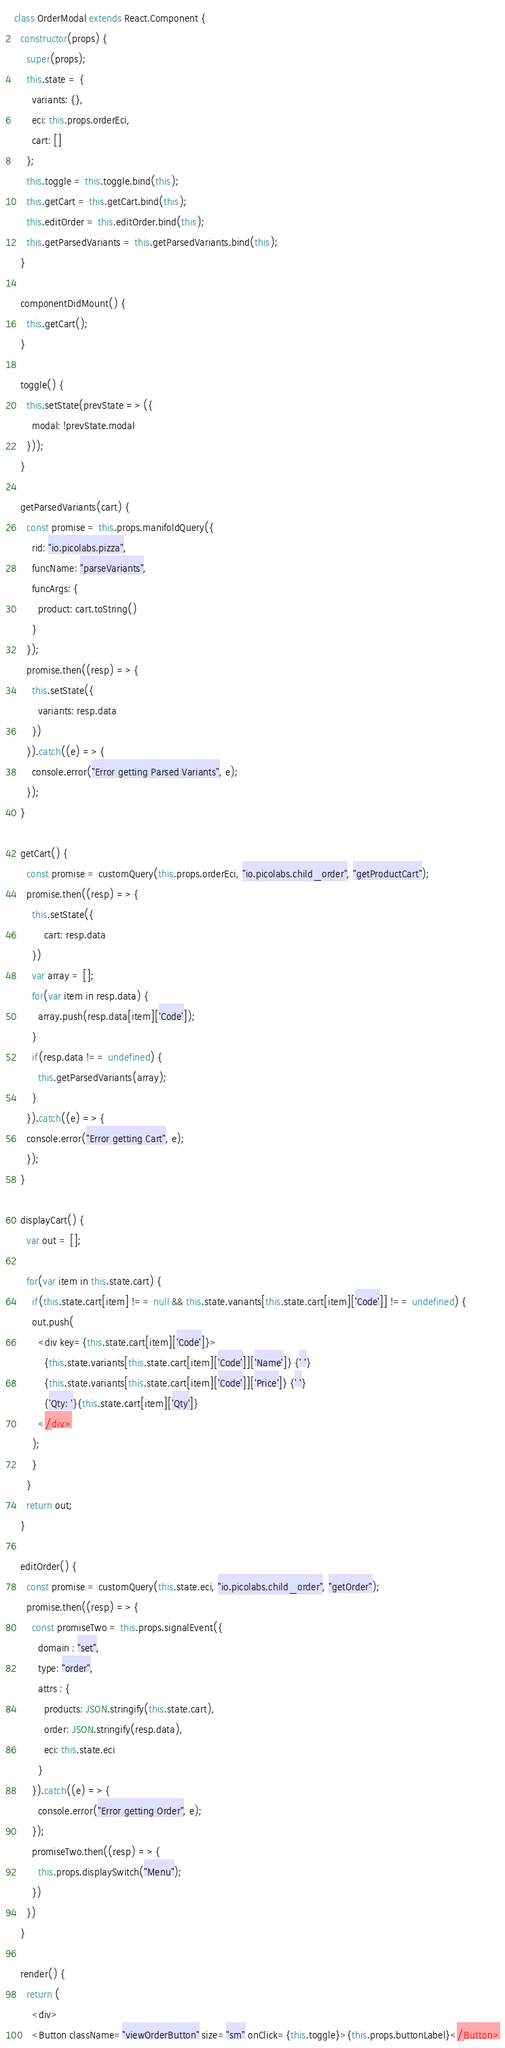<code> <loc_0><loc_0><loc_500><loc_500><_JavaScript_>class OrderModal extends React.Component {
  constructor(props) {
    super(props);
    this.state = {
      variants: {},
      eci: this.props.orderEci,
      cart: []
    };
    this.toggle = this.toggle.bind(this);
    this.getCart = this.getCart.bind(this);
    this.editOrder = this.editOrder.bind(this);
    this.getParsedVariants = this.getParsedVariants.bind(this);
  }

  componentDidMount() {
    this.getCart();
  }

  toggle() {
    this.setState(prevState => ({
      modal: !prevState.modal
    }));
  }

  getParsedVariants(cart) {
    const promise = this.props.manifoldQuery({
      rid: "io.picolabs.pizza",
      funcName: "parseVariants",
      funcArgs: {
        product: cart.toString()
      }
    });
    promise.then((resp) => {
      this.setState({
        variants: resp.data
      })
    }).catch((e) => {
      console.error("Error getting Parsed Variants", e);
    });
  }

  getCart() {
    const promise = customQuery(this.props.orderEci, "io.picolabs.child_order", "getProductCart");
    promise.then((resp) => {
      this.setState({
          cart: resp.data
      })
      var array = [];
      for(var item in resp.data) {
        array.push(resp.data[item]['Code']);
      }
      if(resp.data !== undefined) {
        this.getParsedVariants(array);
      }
    }).catch((e) => {
    console.error("Error getting Cart", e);
    });
  }

  displayCart() {
    var out = [];

    for(var item in this.state.cart) {
      if(this.state.cart[item] !== null && this.state.variants[this.state.cart[item]['Code']] !== undefined) {
      out.push(
        <div key={this.state.cart[item]['Code']}>
          {this.state.variants[this.state.cart[item]['Code']]['Name']} {' '}
          {this.state.variants[this.state.cart[item]['Code']]['Price']} {' '}
          {'Qty: '}{this.state.cart[item]['Qty']}
        </div>
      );
      }
    }
    return out;
  }

  editOrder() {
    const promise = customQuery(this.state.eci, "io.picolabs.child_order", "getOrder");
    promise.then((resp) => {
      const promiseTwo = this.props.signalEvent({
        domain : "set",
        type: "order",
        attrs : {
          products: JSON.stringify(this.state.cart),
          order: JSON.stringify(resp.data),
          eci: this.state.eci
        }
      }).catch((e) => {
        console.error("Error getting Order", e);
      });
      promiseTwo.then((resp) => {
        this.props.displaySwitch("Menu");
      })
    })
  }

  render() {
    return (
      <div>
      <Button className="viewOrderButton" size="sm" onClick={this.toggle}>{this.props.buttonLabel}</Button></code> 